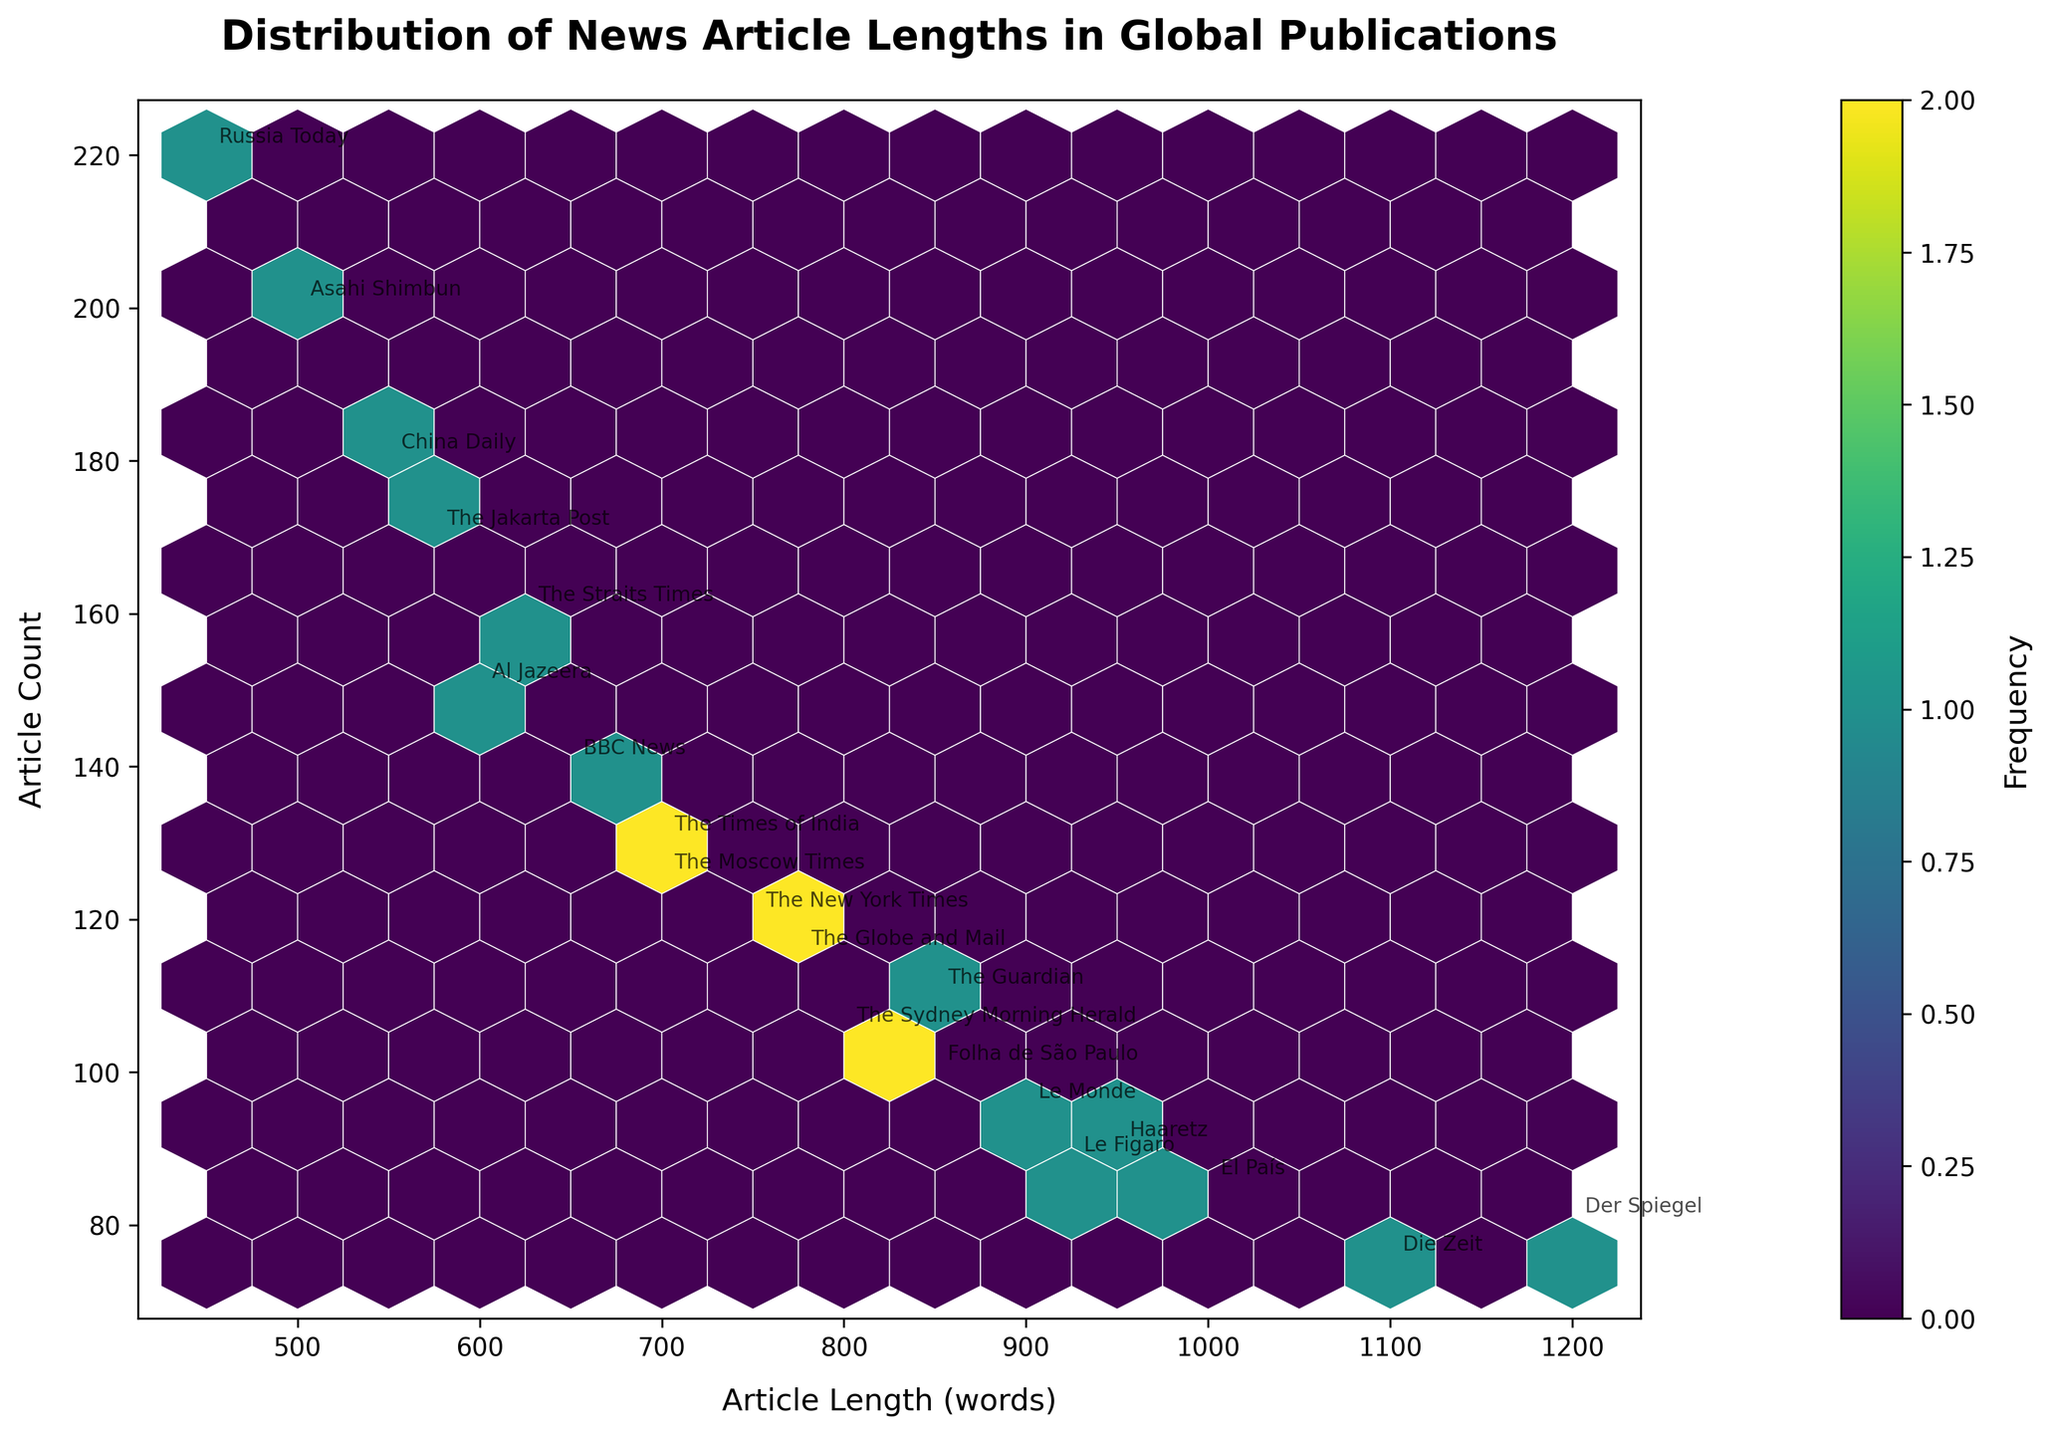What is the title of the plot? The title is usually located at the top of the plot and provides a brief description of what the plot is about. In this case, it reads "Distribution of News Article Lengths in Global Publications". This is directly visible on the plot.
Answer: Distribution of News Article Lengths in Global Publications What are the labels of the X and Y axes? The X-axis label is "Article Length (words)", and the Y-axis label is "Article Count". These labels usually explain what each axis represents and are clearly visible on the plot.
Answer: Article Length (words), Article Count Which publication has the highest article count? You can determine this by looking for the data point with the highest value on the Y-axis. The figure shows "Russia Today" at the highest point on the Y-axis with an article count of 220.
Answer: Russia Today Which publication has the longest average article length? By looking at the X-axis, the publication with the farthest data point to the right is "Der Spiegel" with an article length of 1200 words.
Answer: Der Spiegel Are there any publications with more than 200 articles? By looking at the Y-axis, "Asahi Shimbun" and "Russia Today" have article counts greater than 200.
Answer: Asahi Shimbun and Russia Today How many levels of frequency are shown in the color bar? The color bar shows the frequency of data points within each hexbin. By counting the color segments, there are five levels of frequency represented from light to dark.
Answer: Five Which two publications have similar article lengths but different article counts? "The Times of India" and "The Moscow Times" both have article lengths of 700 words but different article counts, with 130 and 125 respectively.
Answer: The Times of India and The Moscow Times What is the median article length among the listed publications? The median is the middle value in a sorted list. Sorting the article lengths: 450, 500, 550, 575, 600, 625, 650, 700, 700, 750, 775, 800, 850, 850, 900, 925, 950, 1000, 1100, 1200. The middle values are 750 and 775, so the average is (750+775)/2 = 762.5.
Answer: 762.5 Which region on the plot shows the highest density of points? The color gradient indicates density, with darker colors showing higher densities. The region around (600-700, 120-130) appears the densest.
Answer: Around (600-700, 120-130) How is the frequency represented in this hexbin plot, and what does it tell you? Frequency is represented by the color intensity in the hexagonal bins, where darker colors indicate a higher frequency of articles within that bin. This tells us which ranges of article lengths and counts are most common.
Answer: By color intensity, darker indicates higher frequency 